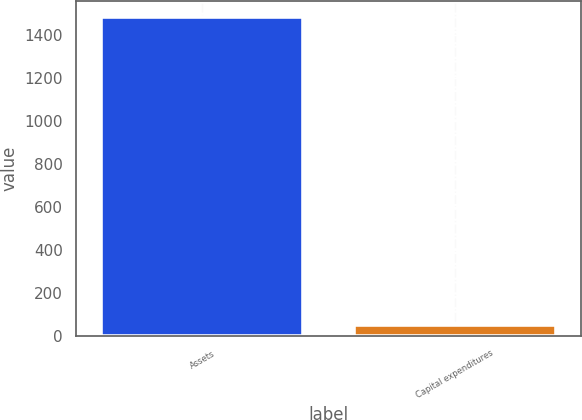Convert chart. <chart><loc_0><loc_0><loc_500><loc_500><bar_chart><fcel>Assets<fcel>Capital expenditures<nl><fcel>1482<fcel>51<nl></chart> 